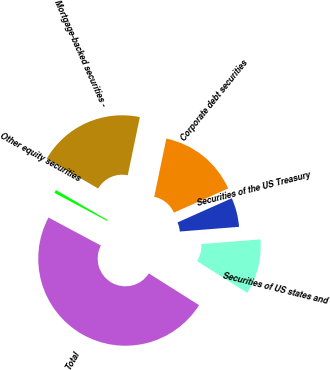Convert chart. <chart><loc_0><loc_0><loc_500><loc_500><pie_chart><fcel>Securities of US states and<fcel>Securities of the US Treasury<fcel>Corporate debt securities<fcel>Mortgage-backed securities -<fcel>Other equity securities<fcel>Total<nl><fcel>10.23%<fcel>5.41%<fcel>15.06%<fcel>19.88%<fcel>0.58%<fcel>48.83%<nl></chart> 